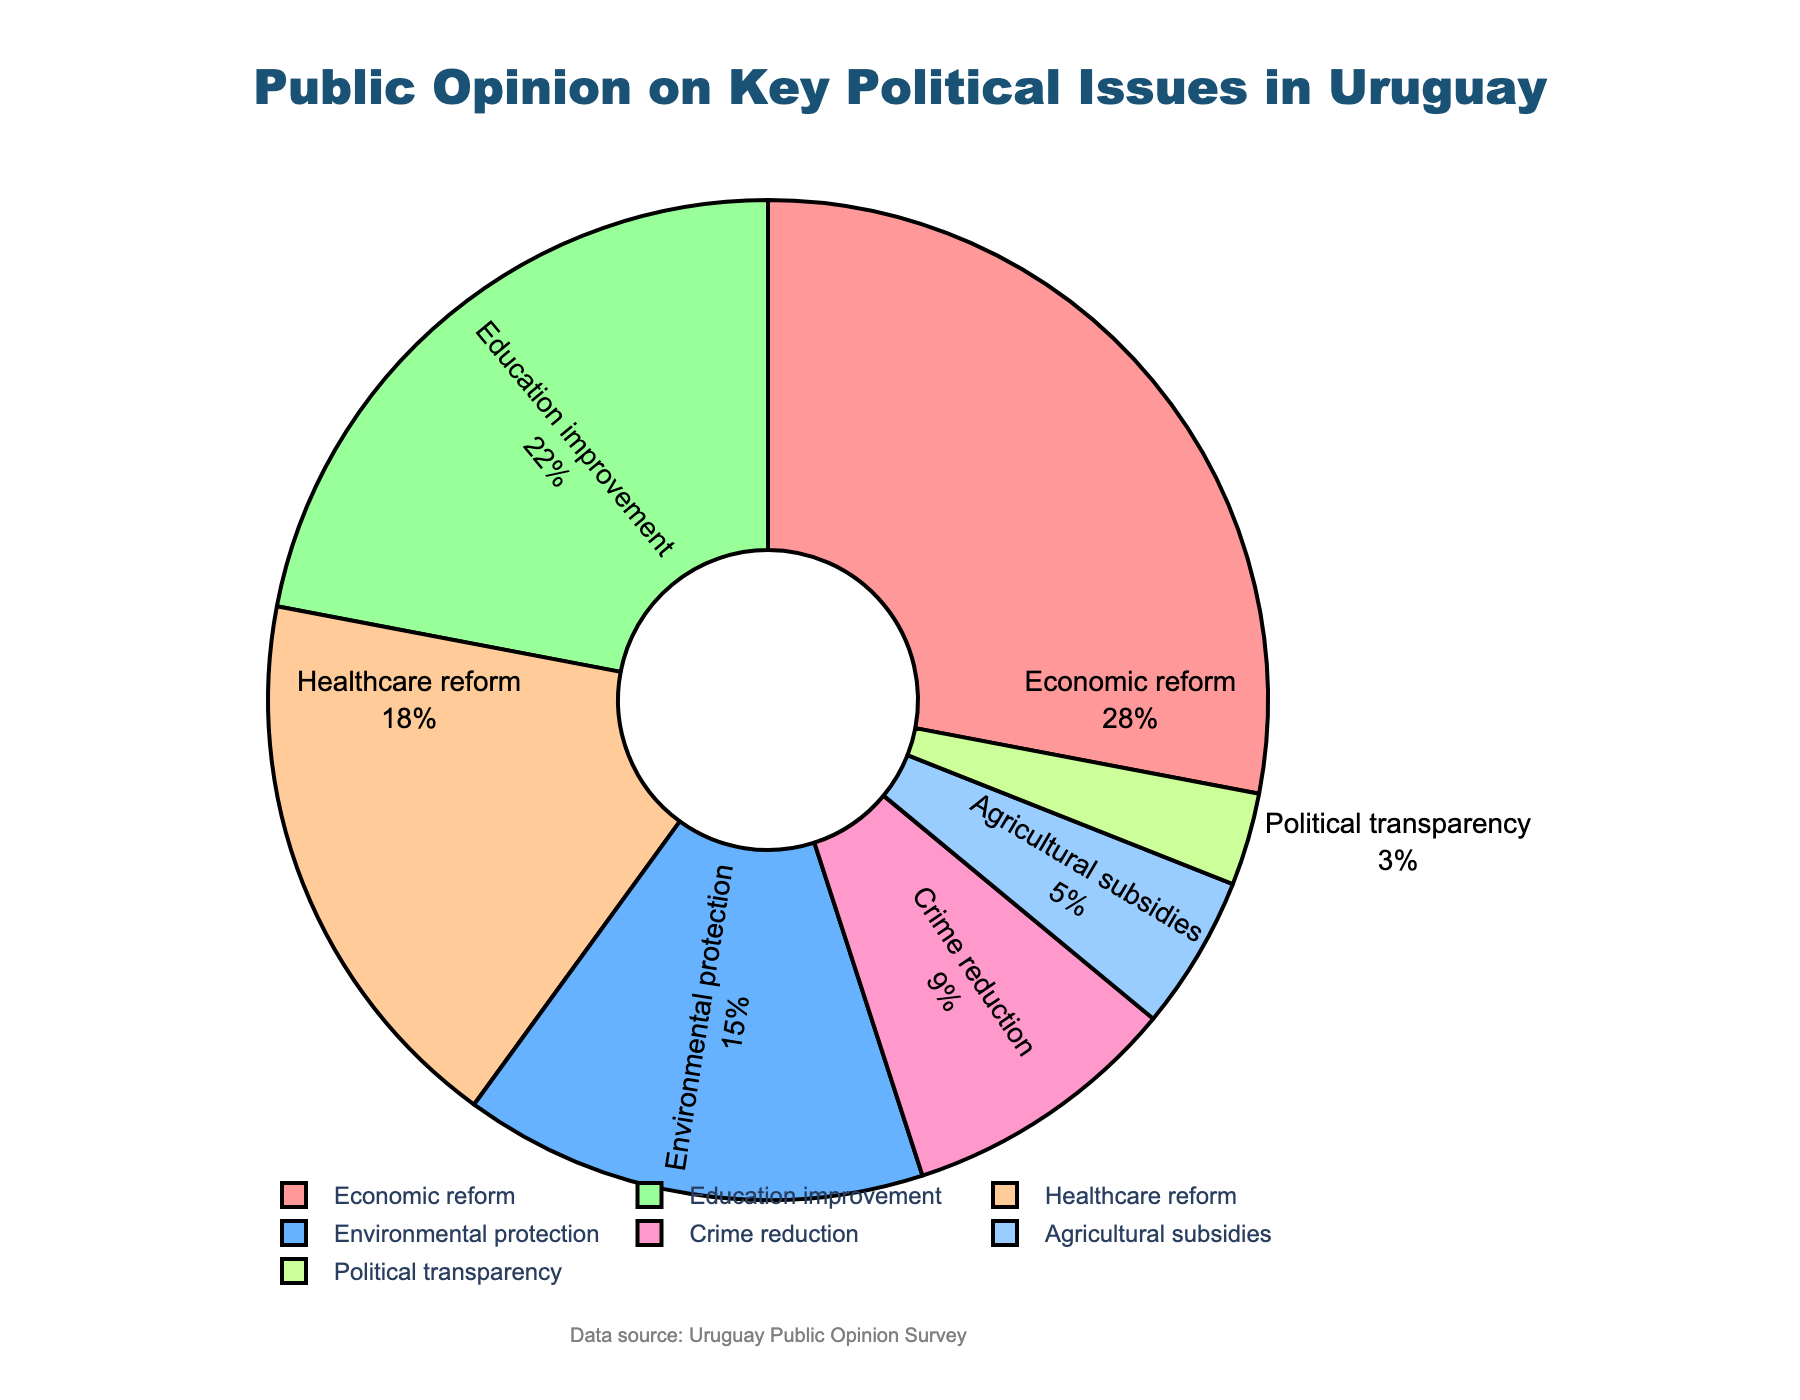Which political issue has the highest percentage of support? The largest segment of the pie chart should correspond to the issue with the highest percentage. The issue with the highest percentage of support is Economic reform, which is shown as 28%.
Answer: Economic reform What is the total percentage of support for Education improvement and Healthcare reform combined? To find the total support for these two issues, add their individual percentages together: 22% (Education improvement) + 18% (Healthcare reform) = 40%.
Answer: 40% Which issue has the lowest percentage of support, and what percentage does it have? The smallest segment of the pie chart represents the issue with the lowest percentage. The issue with the lowest support is Political transparency, with 3%.
Answer: Political transparency Compare the support for Economic reform and Environmental protection. Which one has more support and by how much? Economic reform has 28% support, and Environmental protection has 15% support. To find the difference, subtract the smaller percentage from the larger one: 28% - 15% = 13%. Economic reform has 13% more support.
Answer: Economic reform by 13% What is the combined percentage of support for all issues except Economic reform? First, subtract the Economic reform percentage from 100%: 100% - 28% = 72%. This is the combined support for all other issues.
Answer: 72% What is the difference in support between Crime reduction and Agricultural subsidies? Crime reduction has 9% support, and Agricultural subsidies have 5% support. The difference is found by subtracting 5% from 9%, which equals 4%.
Answer: 4% If you group Healthcare reform and Crime reduction together, what is the total percentage of their support, and how does it compare to Economic reform? Sum the percentages of Healthcare reform (18%) and Crime reduction (9%): 18% + 9% = 27%. Economic reform has 28% support, so combined Healthcare reform and Crime reduction are 1% less than Economic reform (28% - 27%).
Answer: 27%, 1% less How many percent higher is the support for Education improvement compared to Agricultural subsidies? Education improvement has 22% support while Agricultural subsidies have 5%. Subtract 5% from 22% to find the difference: 22% - 5% = 17%.
Answer: 17% Rank the issues by support from highest to lowest percentage. Order the percentages from the highest to the lowest: Economic reform (28%), Education improvement (22%), Healthcare reform (18%), Environmental protection (15%), Crime reduction (9%), Agricultural subsidies (5%), and Political transparency (3%).
Answer: Economic reform, Education improvement, Healthcare reform, Environmental protection, Crime reduction, Agricultural subsidies, Political transparency What is the average percentage of support for all the issues listed? To find the average, sum all the percentages and divide by the number of issues: (28 + 15 + 22 + 18 + 9 + 5 + 3) / 7 = 100 / 7 ≈ 14.29%.
Answer: 14.29% 